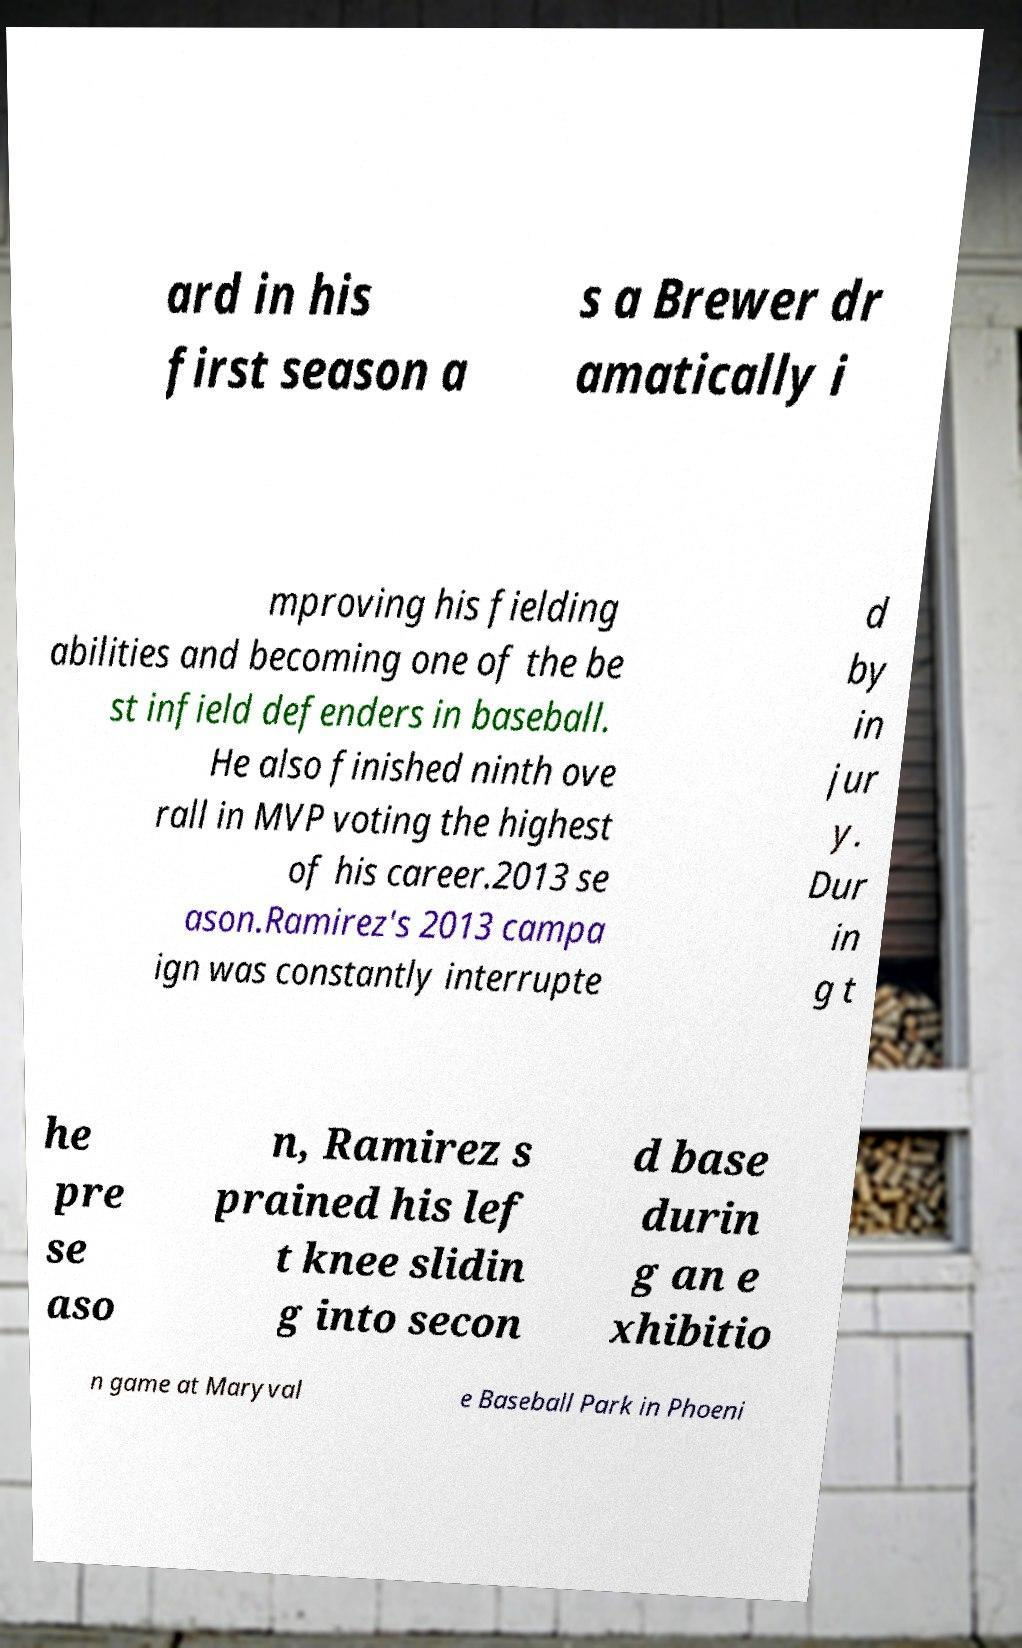Could you extract and type out the text from this image? ard in his first season a s a Brewer dr amatically i mproving his fielding abilities and becoming one of the be st infield defenders in baseball. He also finished ninth ove rall in MVP voting the highest of his career.2013 se ason.Ramirez's 2013 campa ign was constantly interrupte d by in jur y. Dur in g t he pre se aso n, Ramirez s prained his lef t knee slidin g into secon d base durin g an e xhibitio n game at Maryval e Baseball Park in Phoeni 